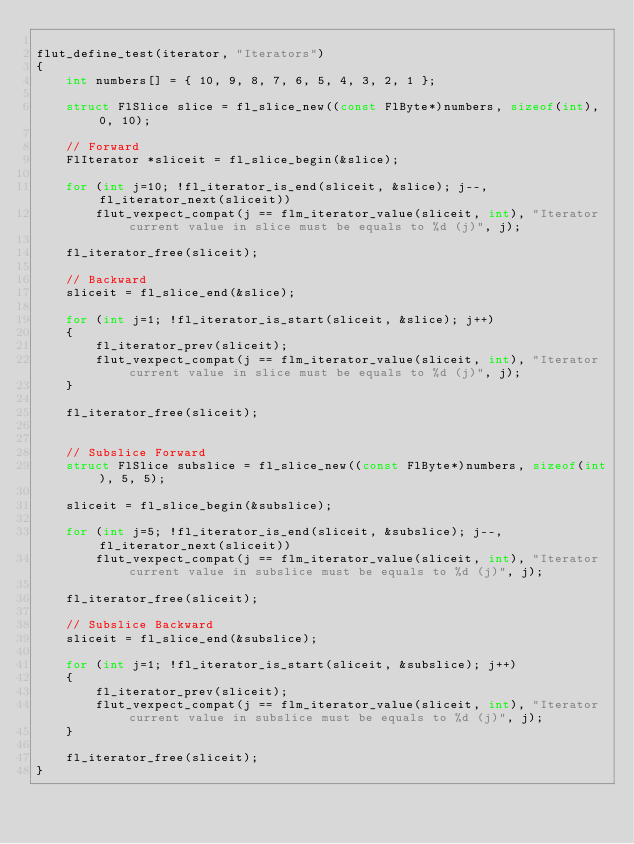Convert code to text. <code><loc_0><loc_0><loc_500><loc_500><_C_>
flut_define_test(iterator, "Iterators")
{
    int numbers[] = { 10, 9, 8, 7, 6, 5, 4, 3, 2, 1 };

    struct FlSlice slice = fl_slice_new((const FlByte*)numbers, sizeof(int), 0, 10);

    // Forward
    FlIterator *sliceit = fl_slice_begin(&slice);

    for (int j=10; !fl_iterator_is_end(sliceit, &slice); j--, fl_iterator_next(sliceit))
        flut_vexpect_compat(j == flm_iterator_value(sliceit, int), "Iterator current value in slice must be equals to %d (j)", j);

    fl_iterator_free(sliceit);

    // Backward
    sliceit = fl_slice_end(&slice);

    for (int j=1; !fl_iterator_is_start(sliceit, &slice); j++)
    {
        fl_iterator_prev(sliceit);
        flut_vexpect_compat(j == flm_iterator_value(sliceit, int), "Iterator current value in slice must be equals to %d (j)", j);
    }

    fl_iterator_free(sliceit);


    // Subslice Forward
    struct FlSlice subslice = fl_slice_new((const FlByte*)numbers, sizeof(int), 5, 5);
    
    sliceit = fl_slice_begin(&subslice);

    for (int j=5; !fl_iterator_is_end(sliceit, &subslice); j--, fl_iterator_next(sliceit))
        flut_vexpect_compat(j == flm_iterator_value(sliceit, int), "Iterator current value in subslice must be equals to %d (j)", j);

    fl_iterator_free(sliceit);

    // Subslice Backward
    sliceit = fl_slice_end(&subslice);

    for (int j=1; !fl_iterator_is_start(sliceit, &subslice); j++)
    {
        fl_iterator_prev(sliceit);
        flut_vexpect_compat(j == flm_iterator_value(sliceit, int), "Iterator current value in subslice must be equals to %d (j)", j);
    }

    fl_iterator_free(sliceit);
}
</code> 